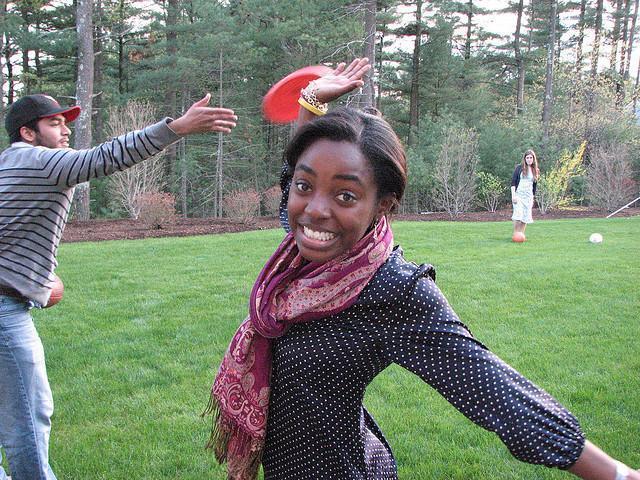How many people can be seen?
Give a very brief answer. 2. 